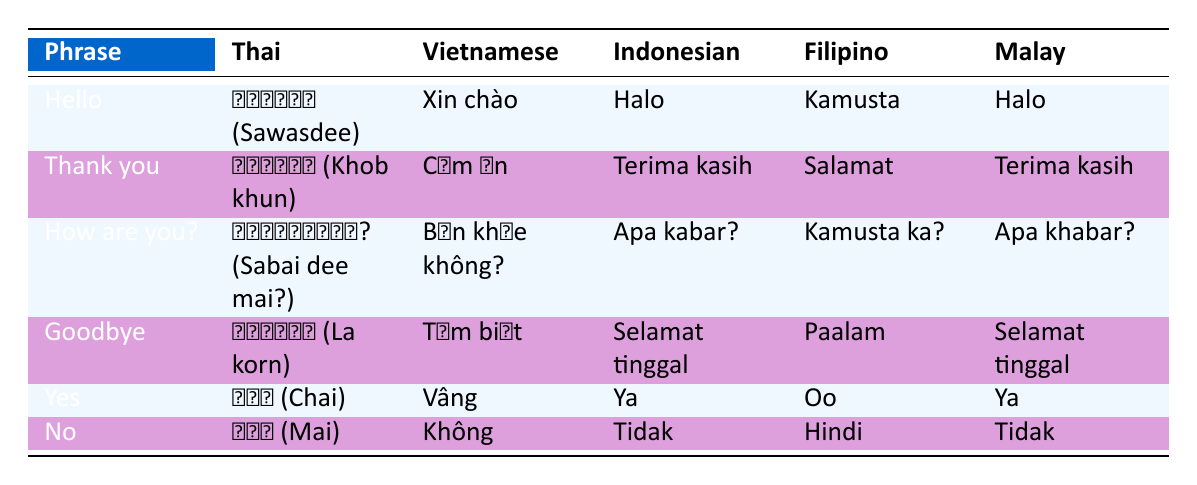What is the Thai phrase for "Goodbye"? Looking at the table under the "Thai" column for the phrase "Goodbye", the corresponding phrase is "ลาก่อน (La korn)".
Answer: ลาก่อน (La korn) How do you say "Thank you" in Filipino? In the table, under the "Filipino" column, for the phrase "Thank you", the phrase is "Salamat".
Answer: Salamat Are "Halo" and "Kamusta" the same phrase in different languages? "Halo" is used for "Hello" in both Indonesian and Malay, while "Kamusta" is used for "Hello" in Filipino. They are not the same; they are greetings in different languages.
Answer: No Which phrases are the same in both Indonesian and Malay? By examining the table for phrases listed under both the Indonesian and Malay columns, I find that "Thank you" (Terima kasih) and "Goodbye" (Selamat tinggal) are the same in both languages.
Answer: Thank you and Goodbye What is the average number of characters in the Thai phrases given in the table? Counting the characters in each Thai phrase: "สวัสดี (Sawasdee)" has 14 characters, "ขอบคุณ (Khob khun)" has 15, "สบายดีไหม? (Sabai dee mai?)" has 20, "ลาก่อน (La korn)" has 10, "ใช่ (Chai)" has 7, and "ไม่ (Mai)" has 6. The sum is 72 characters and dividing by 6 (the number of phrases) gives an average of 12 characters per phrase.
Answer: 12 What is the Vietnamese phrase for "How are you?" Looking under the "Vietnamese" column for the phrase "How are you?", I find it is "Bạn khỏe không?".
Answer: Bạn khỏe không? 